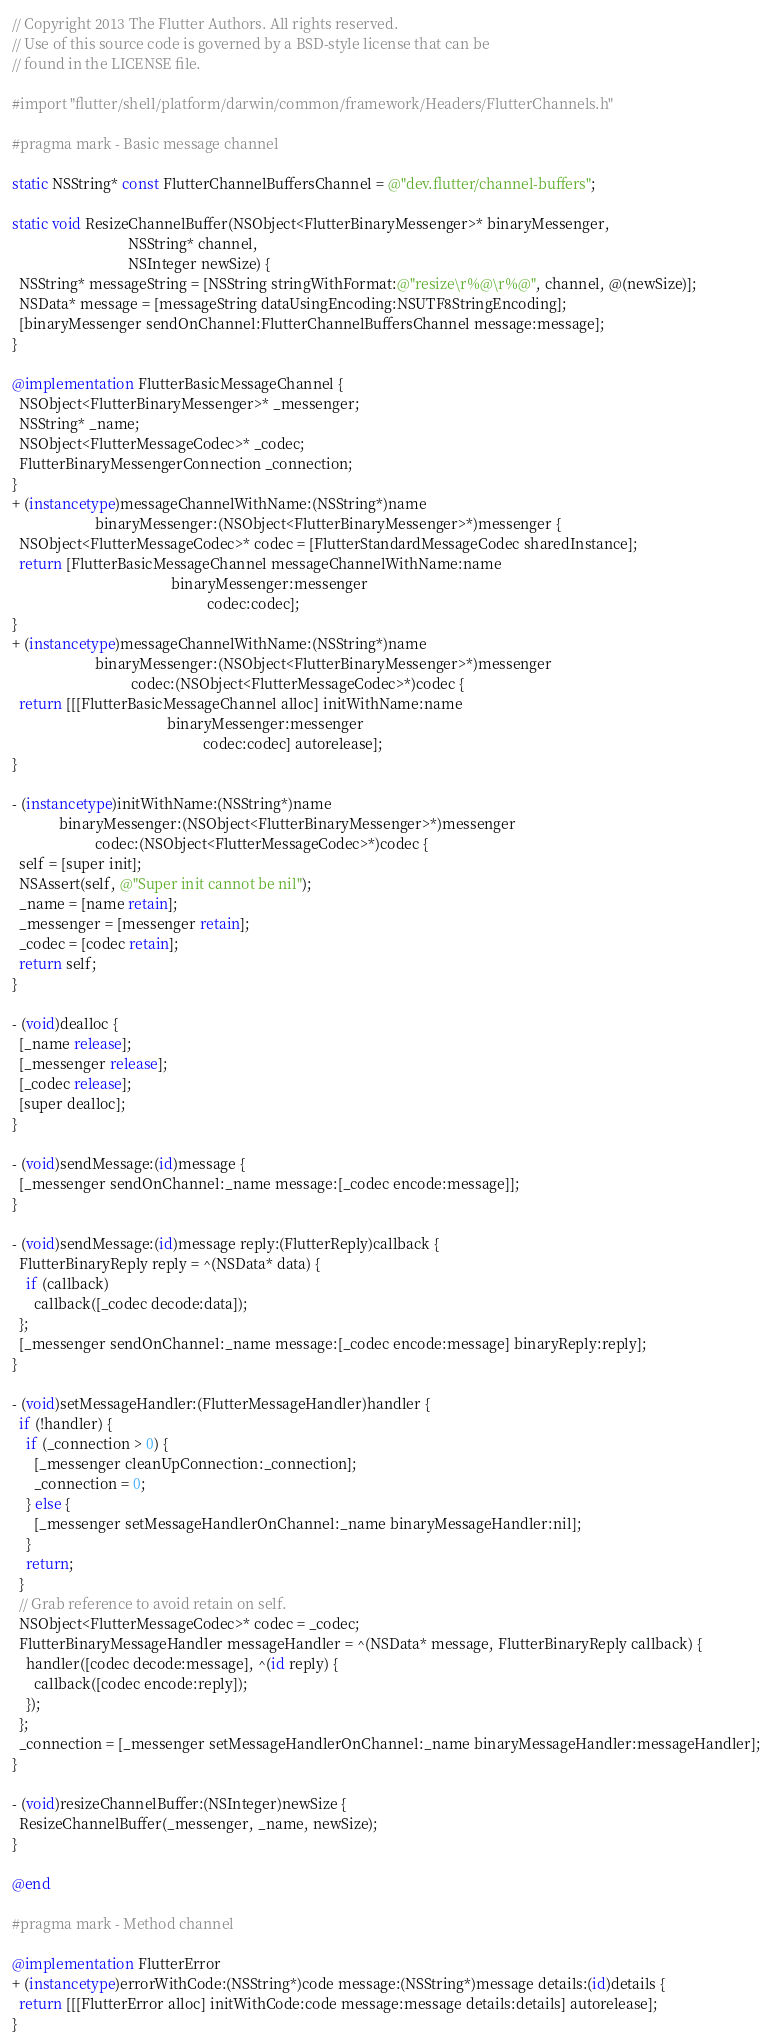Convert code to text. <code><loc_0><loc_0><loc_500><loc_500><_ObjectiveC_>// Copyright 2013 The Flutter Authors. All rights reserved.
// Use of this source code is governed by a BSD-style license that can be
// found in the LICENSE file.

#import "flutter/shell/platform/darwin/common/framework/Headers/FlutterChannels.h"

#pragma mark - Basic message channel

static NSString* const FlutterChannelBuffersChannel = @"dev.flutter/channel-buffers";

static void ResizeChannelBuffer(NSObject<FlutterBinaryMessenger>* binaryMessenger,
                                NSString* channel,
                                NSInteger newSize) {
  NSString* messageString = [NSString stringWithFormat:@"resize\r%@\r%@", channel, @(newSize)];
  NSData* message = [messageString dataUsingEncoding:NSUTF8StringEncoding];
  [binaryMessenger sendOnChannel:FlutterChannelBuffersChannel message:message];
}

@implementation FlutterBasicMessageChannel {
  NSObject<FlutterBinaryMessenger>* _messenger;
  NSString* _name;
  NSObject<FlutterMessageCodec>* _codec;
  FlutterBinaryMessengerConnection _connection;
}
+ (instancetype)messageChannelWithName:(NSString*)name
                       binaryMessenger:(NSObject<FlutterBinaryMessenger>*)messenger {
  NSObject<FlutterMessageCodec>* codec = [FlutterStandardMessageCodec sharedInstance];
  return [FlutterBasicMessageChannel messageChannelWithName:name
                                            binaryMessenger:messenger
                                                      codec:codec];
}
+ (instancetype)messageChannelWithName:(NSString*)name
                       binaryMessenger:(NSObject<FlutterBinaryMessenger>*)messenger
                                 codec:(NSObject<FlutterMessageCodec>*)codec {
  return [[[FlutterBasicMessageChannel alloc] initWithName:name
                                           binaryMessenger:messenger
                                                     codec:codec] autorelease];
}

- (instancetype)initWithName:(NSString*)name
             binaryMessenger:(NSObject<FlutterBinaryMessenger>*)messenger
                       codec:(NSObject<FlutterMessageCodec>*)codec {
  self = [super init];
  NSAssert(self, @"Super init cannot be nil");
  _name = [name retain];
  _messenger = [messenger retain];
  _codec = [codec retain];
  return self;
}

- (void)dealloc {
  [_name release];
  [_messenger release];
  [_codec release];
  [super dealloc];
}

- (void)sendMessage:(id)message {
  [_messenger sendOnChannel:_name message:[_codec encode:message]];
}

- (void)sendMessage:(id)message reply:(FlutterReply)callback {
  FlutterBinaryReply reply = ^(NSData* data) {
    if (callback)
      callback([_codec decode:data]);
  };
  [_messenger sendOnChannel:_name message:[_codec encode:message] binaryReply:reply];
}

- (void)setMessageHandler:(FlutterMessageHandler)handler {
  if (!handler) {
    if (_connection > 0) {
      [_messenger cleanUpConnection:_connection];
      _connection = 0;
    } else {
      [_messenger setMessageHandlerOnChannel:_name binaryMessageHandler:nil];
    }
    return;
  }
  // Grab reference to avoid retain on self.
  NSObject<FlutterMessageCodec>* codec = _codec;
  FlutterBinaryMessageHandler messageHandler = ^(NSData* message, FlutterBinaryReply callback) {
    handler([codec decode:message], ^(id reply) {
      callback([codec encode:reply]);
    });
  };
  _connection = [_messenger setMessageHandlerOnChannel:_name binaryMessageHandler:messageHandler];
}

- (void)resizeChannelBuffer:(NSInteger)newSize {
  ResizeChannelBuffer(_messenger, _name, newSize);
}

@end

#pragma mark - Method channel

@implementation FlutterError
+ (instancetype)errorWithCode:(NSString*)code message:(NSString*)message details:(id)details {
  return [[[FlutterError alloc] initWithCode:code message:message details:details] autorelease];
}
</code> 